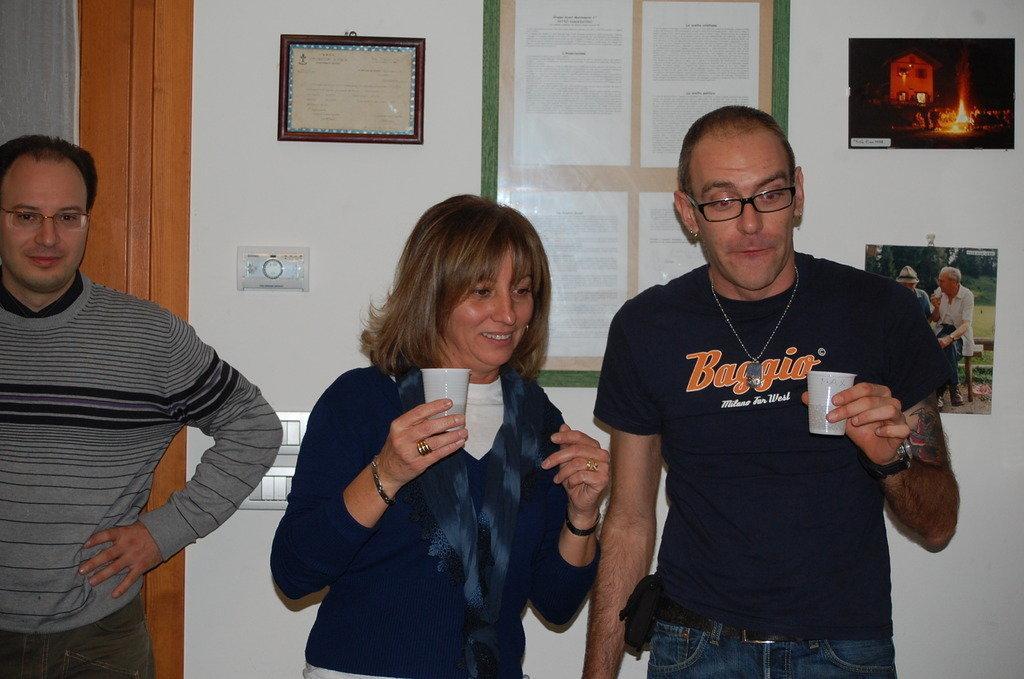In one or two sentences, can you explain what this image depicts? In the foreground, I can see three persons are standing on the floor and are holding glasses in their hand. In the background, I can see photo frames on a wall, boards and a door. This image taken, maybe in a room. 